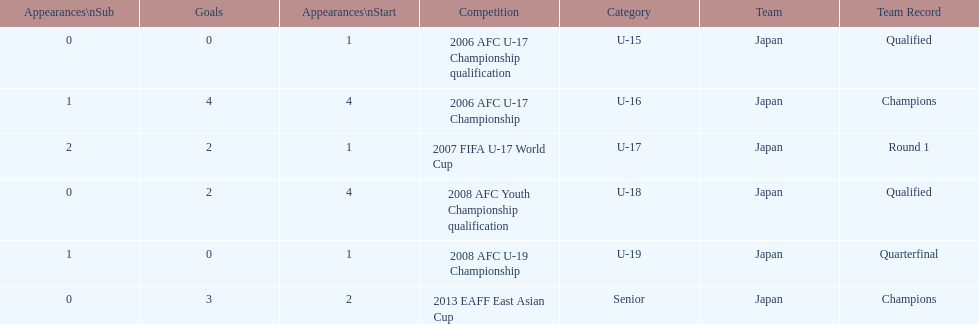Which competition had the highest number of starts and goals? 2006 AFC U-17 Championship. 